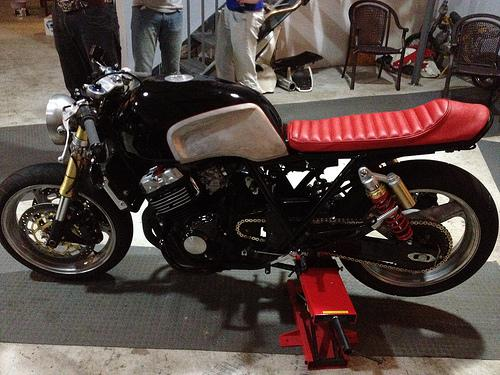Question: what color are the person's pants on the right?
Choices:
A. White.
B. Green.
C. Black.
D. Gray.
Answer with the letter. Answer: A 